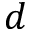Convert formula to latex. <formula><loc_0><loc_0><loc_500><loc_500>d</formula> 